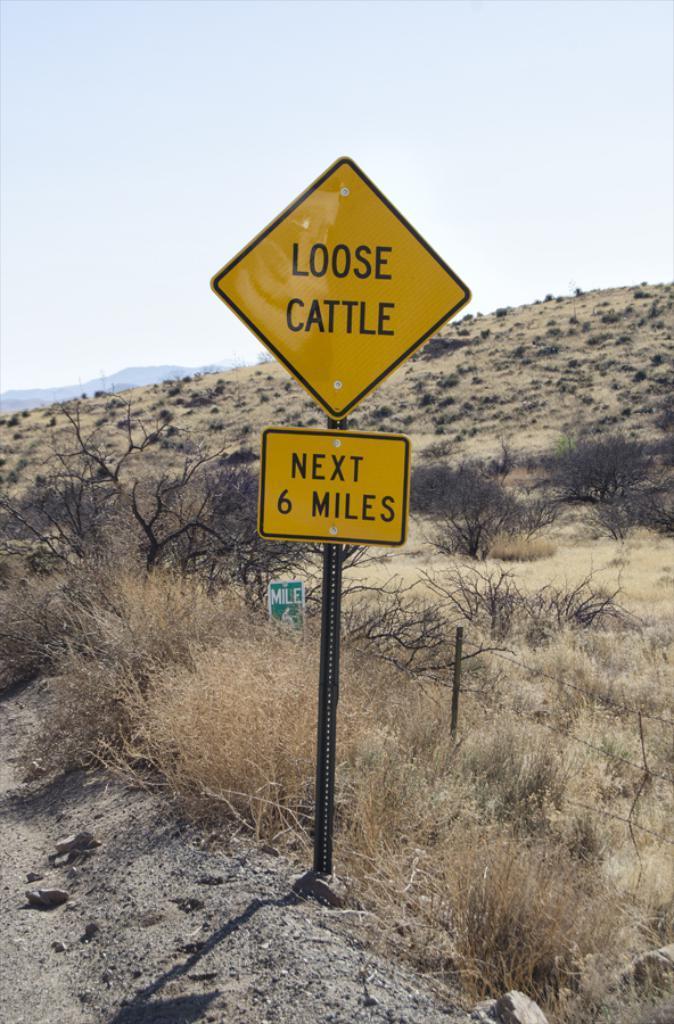Could you give a brief overview of what you see in this image? In this image there is a land and a pole for that pole there are boards, on that board there is some text, in the background there are plants hill and the sky. 